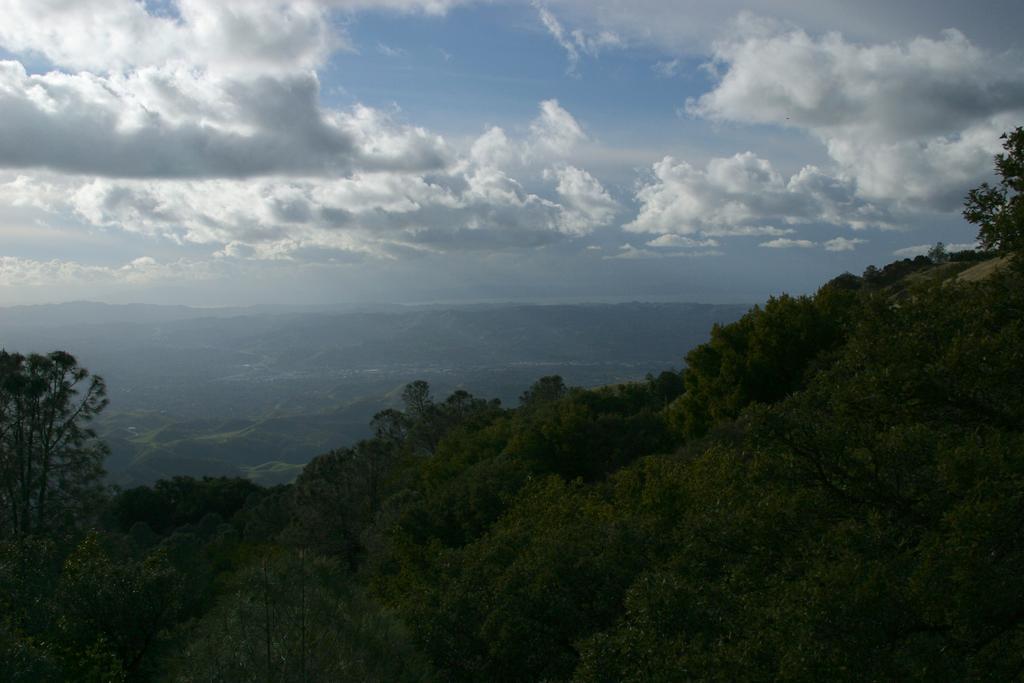Can you describe this image briefly? This image is taken outdoors. At the top of the image there is a sky with clouds. At the bottom of the image there are many trees and plants on the ground. In the background there are a few hills. 